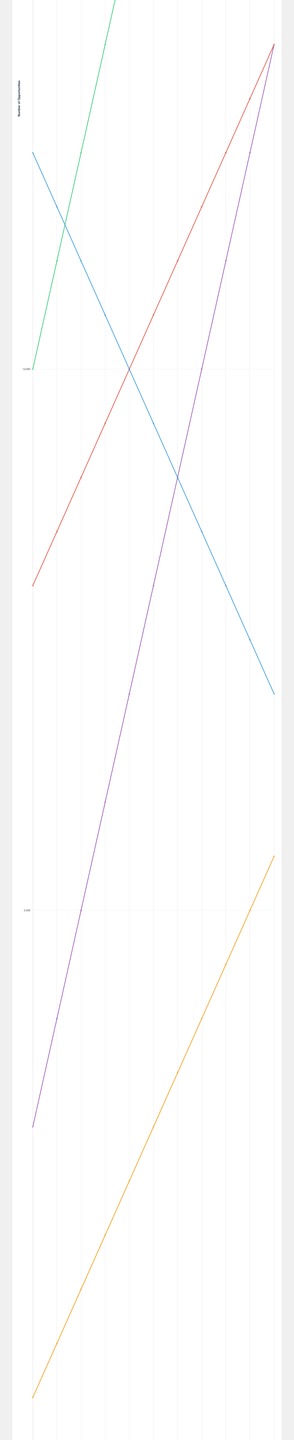What year did online media opportunities surpass print media opportunities? Online media opportunities surpass print media opportunities in 2015. This can be seen by comparing the values for each year: in 2015, online media (12,000) exceeds print media (11,000).
Answer: 2015 Which category saw the highest increase in opportunities from 2013 to 2023? By comparing the values for each category from 2013 to 2023, social media saw the largest increase: from 3,000 opportunities in 2013 to 13,000 in 2023, an increase of 10,000.
Answer: Social Media In what year did podcast opportunities reach 3,500? By examining the dataset, podcast opportunities were at 3,500 in 2019.
Answer: 2019 How does the number of broadcasting opportunities in 2023 compare to 2020? In 2023, broadcasting opportunities are 13,000 versus 11,500 in 2020. So, there is an increase of 1,500 opportunities.
Answer: 1,500 increase What is the sum of all opportunities across all categories for the year 2020? Adding up all opportunities in 2020: Print Media (8,500), Online Media (17,000), Broadcasting (11,500), Podcasts (4,000), Social Media (10,000). Total = 8,500 + 17,000 + 11,500 + 4,000 + 10,000 = 51,000.
Answer: 51,000 Which year experienced the greatest increase in online media opportunities compared to the previous year? The biggest jump in online media opportunities occurs between 2017 and 2018, increasing by 1,000 from 14,000 to 15,000.
Answer: 2018 Compare the trend lines for print media and social media from 2013 to 2023. Print media opportunities show a consistent decline from 12,000 in 2013 to 7,000 in 2023, whereas social media opportunities show a consistent rise from 3,000 in 2013 to 13,000 in 2023.
Answer: Decline (Print Media), Rise (Social Media) 